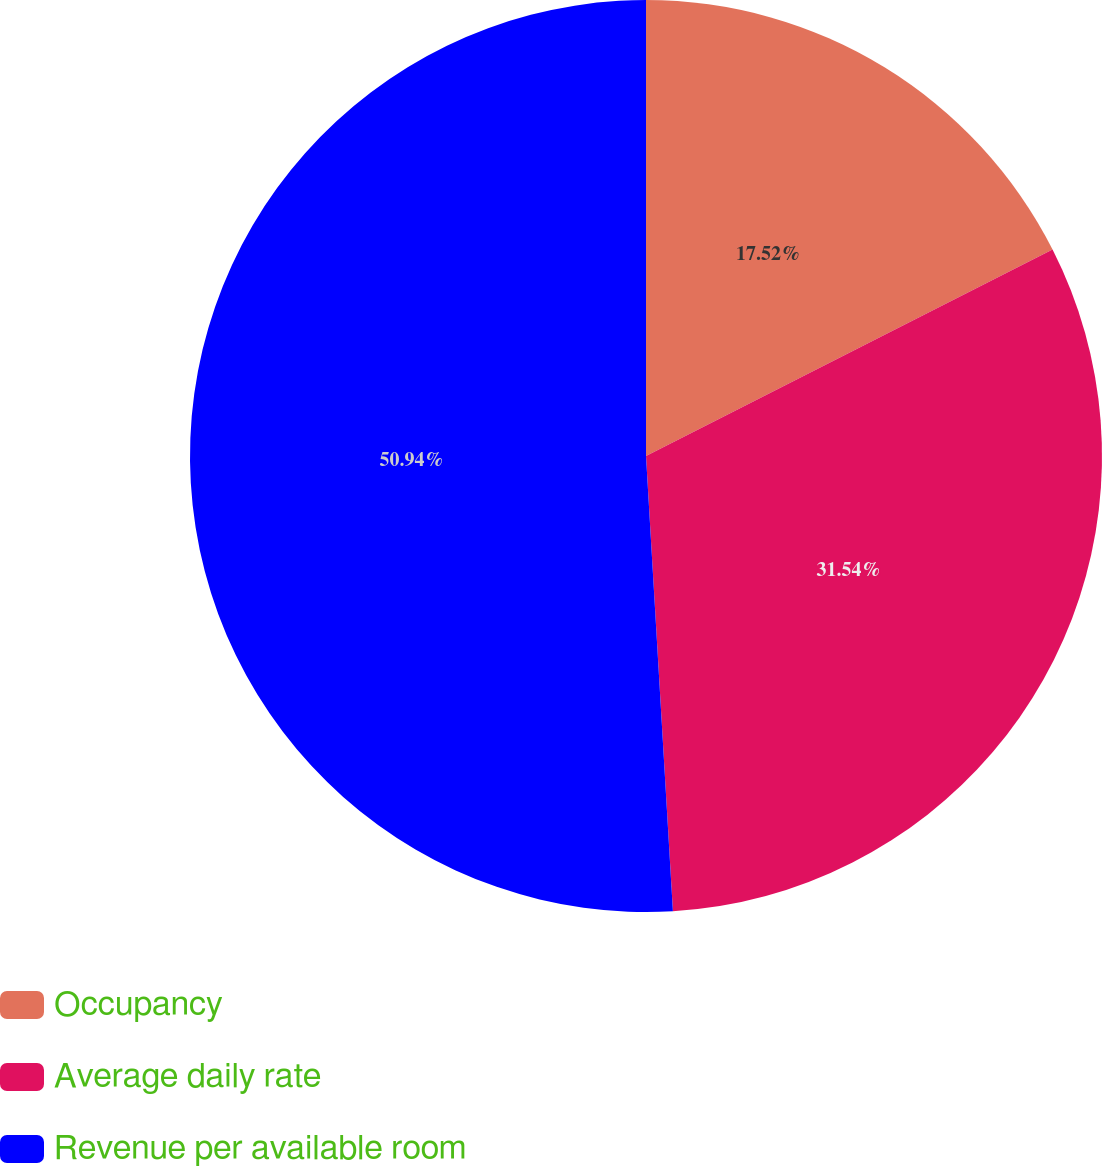Convert chart to OTSL. <chart><loc_0><loc_0><loc_500><loc_500><pie_chart><fcel>Occupancy<fcel>Average daily rate<fcel>Revenue per available room<nl><fcel>17.52%<fcel>31.54%<fcel>50.94%<nl></chart> 